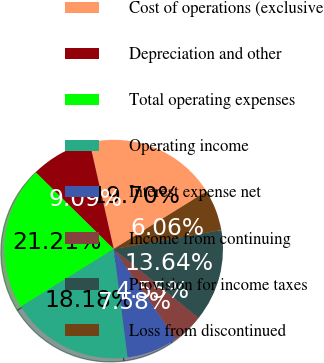Convert chart. <chart><loc_0><loc_0><loc_500><loc_500><pie_chart><fcel>Cost of operations (exclusive<fcel>Depreciation and other<fcel>Total operating expenses<fcel>Operating income<fcel>Interest expense net<fcel>Income from continuing<fcel>Provision for income taxes<fcel>Loss from discontinued<nl><fcel>19.7%<fcel>9.09%<fcel>21.21%<fcel>18.18%<fcel>7.58%<fcel>4.55%<fcel>13.64%<fcel>6.06%<nl></chart> 